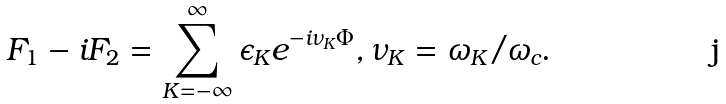Convert formula to latex. <formula><loc_0><loc_0><loc_500><loc_500>F _ { 1 } - i F _ { 2 } = \sum ^ { \infty } _ { K = - \infty } { \epsilon _ { K } e ^ { - i \nu _ { K } \Phi } } , \nu _ { K } = \omega _ { K } / \omega _ { c } .</formula> 